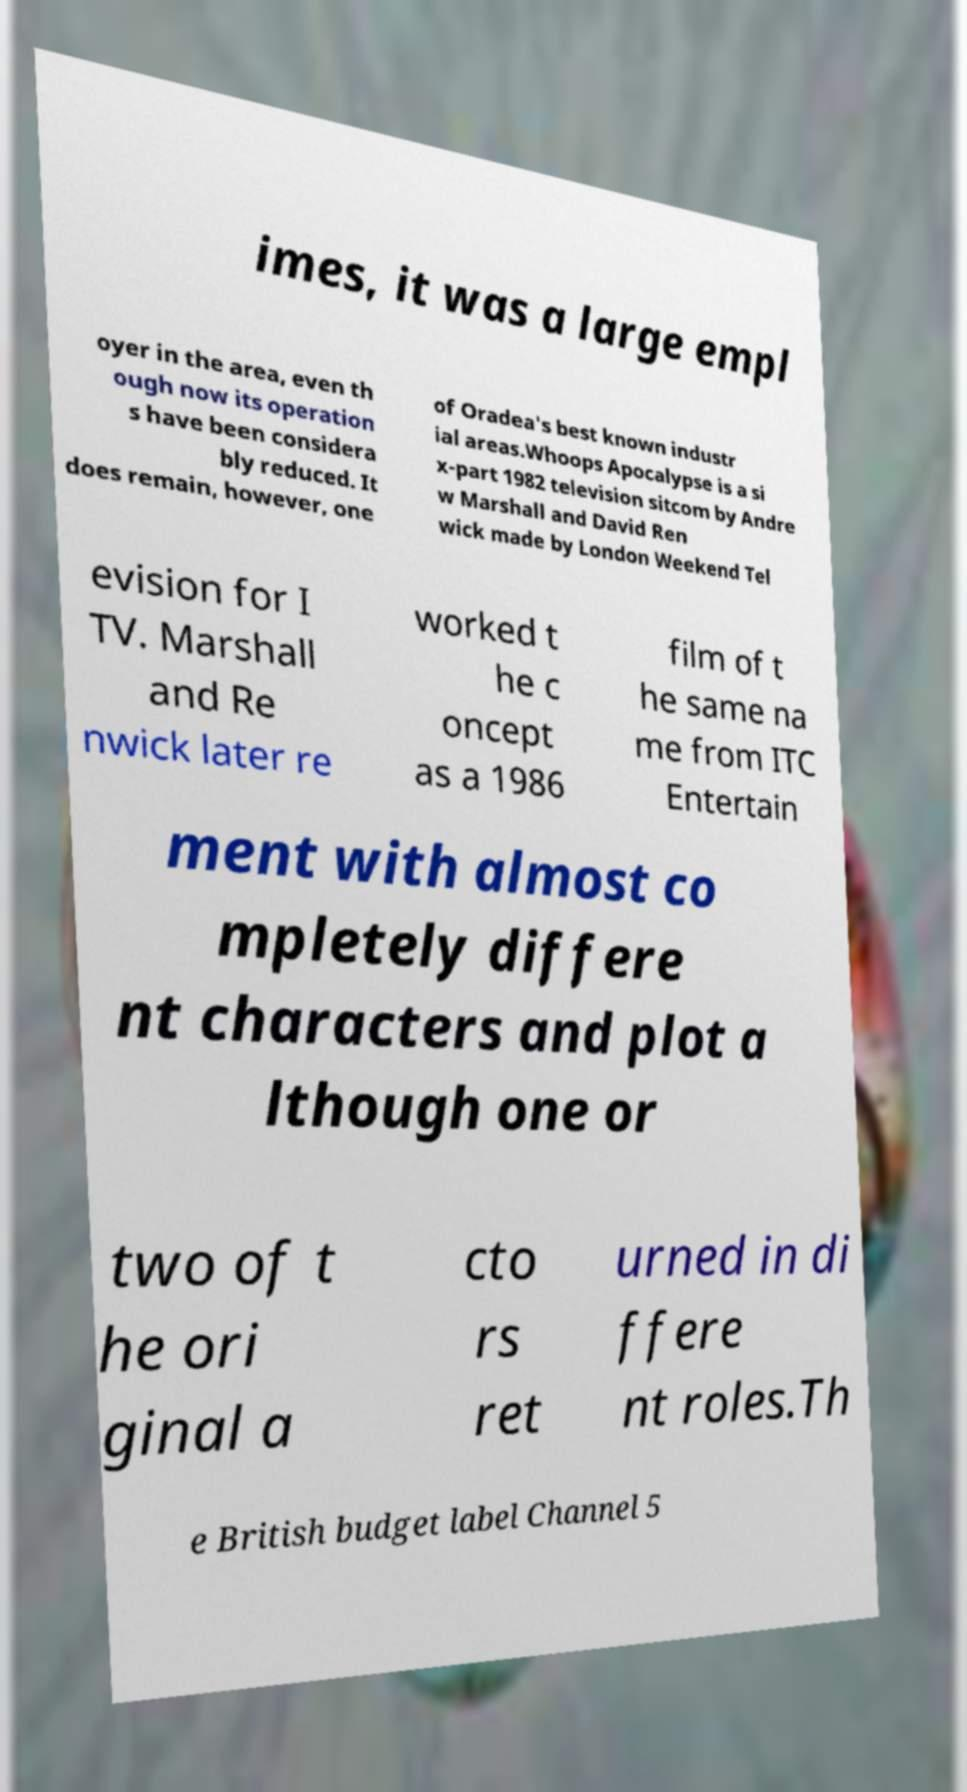Can you read and provide the text displayed in the image?This photo seems to have some interesting text. Can you extract and type it out for me? imes, it was a large empl oyer in the area, even th ough now its operation s have been considera bly reduced. It does remain, however, one of Oradea's best known industr ial areas.Whoops Apocalypse is a si x-part 1982 television sitcom by Andre w Marshall and David Ren wick made by London Weekend Tel evision for I TV. Marshall and Re nwick later re worked t he c oncept as a 1986 film of t he same na me from ITC Entertain ment with almost co mpletely differe nt characters and plot a lthough one or two of t he ori ginal a cto rs ret urned in di ffere nt roles.Th e British budget label Channel 5 